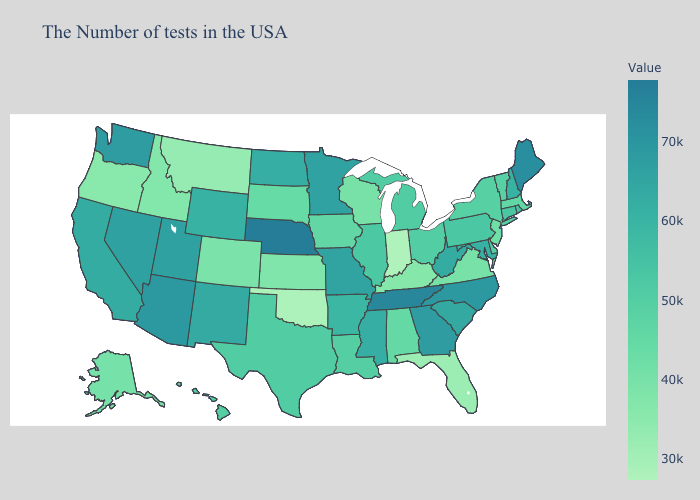Does Rhode Island have the lowest value in the Northeast?
Keep it brief. No. Does the map have missing data?
Concise answer only. No. Among the states that border Wyoming , does Colorado have the lowest value?
Answer briefly. No. Does Indiana have the lowest value in the USA?
Quick response, please. Yes. Does New Jersey have the lowest value in the USA?
Answer briefly. No. Which states have the lowest value in the USA?
Concise answer only. Indiana. Among the states that border Louisiana , does Arkansas have the lowest value?
Quick response, please. No. Does the map have missing data?
Short answer required. No. Does New Mexico have the lowest value in the USA?
Quick response, please. No. Which states hav the highest value in the South?
Keep it brief. Tennessee. 